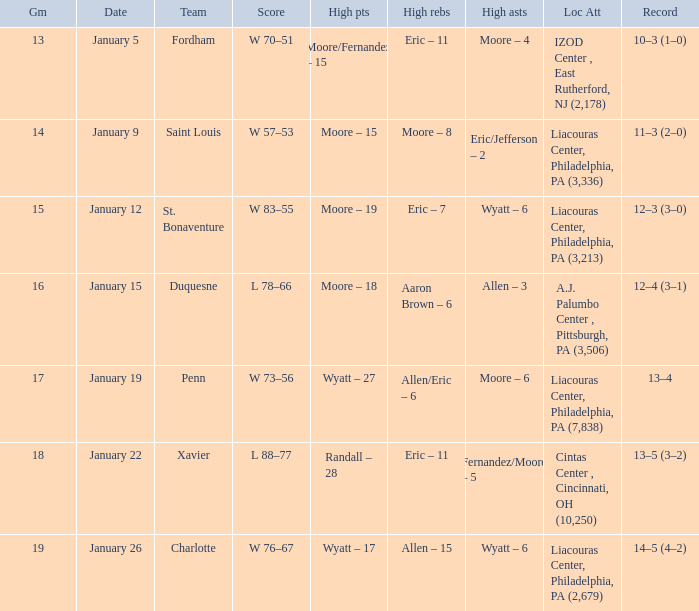What team was Temple playing on January 19? Penn. 